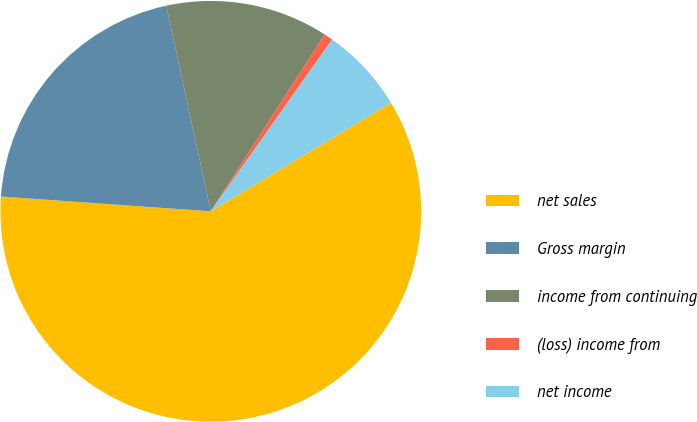<chart> <loc_0><loc_0><loc_500><loc_500><pie_chart><fcel>net sales<fcel>Gross margin<fcel>income from continuing<fcel>(loss) income from<fcel>net income<nl><fcel>59.75%<fcel>20.49%<fcel>12.5%<fcel>0.68%<fcel>6.59%<nl></chart> 